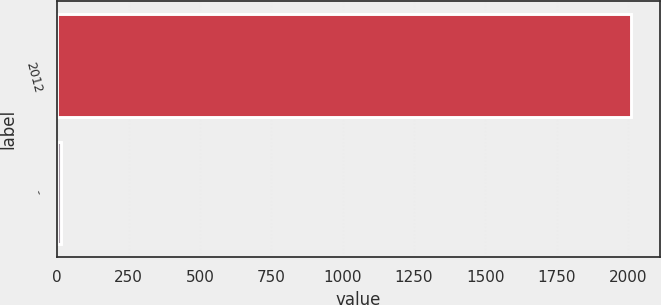Convert chart to OTSL. <chart><loc_0><loc_0><loc_500><loc_500><bar_chart><fcel>2012<fcel>-<nl><fcel>2011<fcel>13.6<nl></chart> 